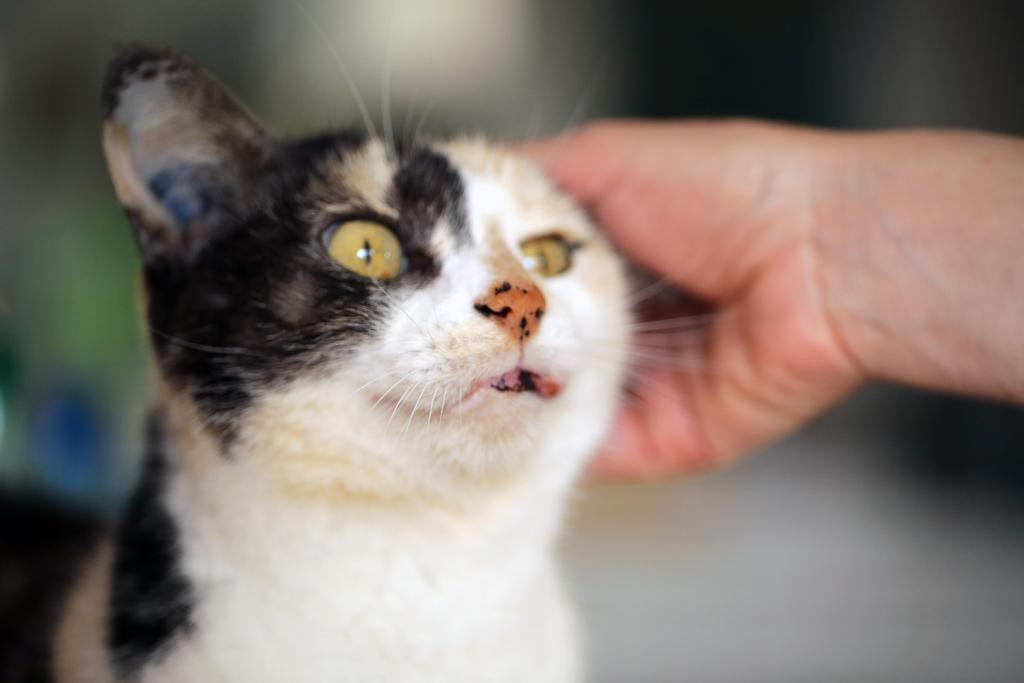What can be seen in the center of the image? There is a cat in the middle of the image. What part of a person is visible in the image? There is a person's hand in the image. Can you describe the background of the image? The background of the image is blurred. What time does the clock show in the image? There is no clock present in the image. What season is depicted in the image? The image does not depict a specific season, as there are no seasonal cues present. 